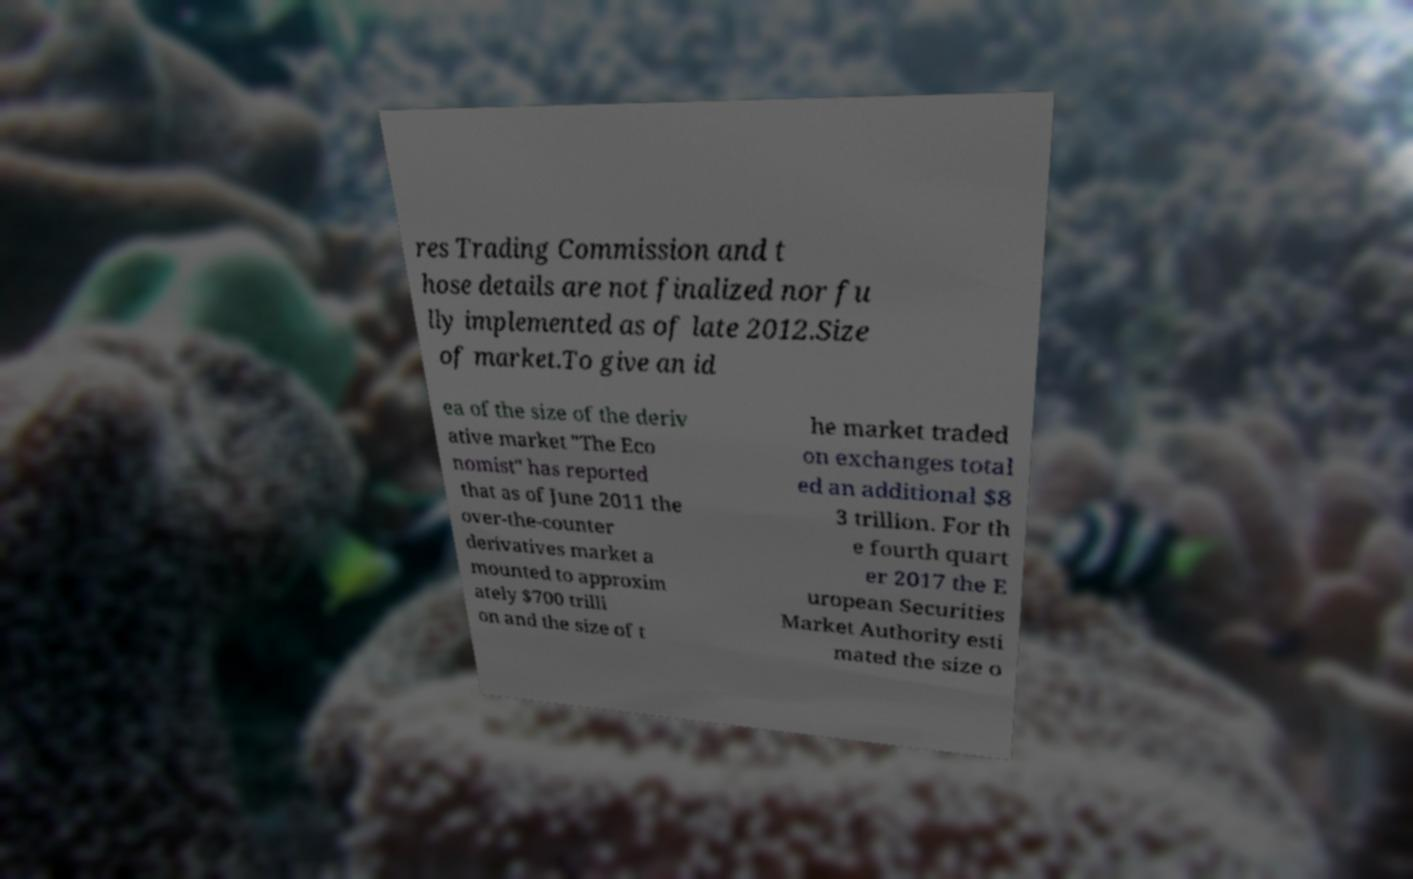For documentation purposes, I need the text within this image transcribed. Could you provide that? res Trading Commission and t hose details are not finalized nor fu lly implemented as of late 2012.Size of market.To give an id ea of the size of the deriv ative market "The Eco nomist" has reported that as of June 2011 the over-the-counter derivatives market a mounted to approxim ately $700 trilli on and the size of t he market traded on exchanges total ed an additional $8 3 trillion. For th e fourth quart er 2017 the E uropean Securities Market Authority esti mated the size o 